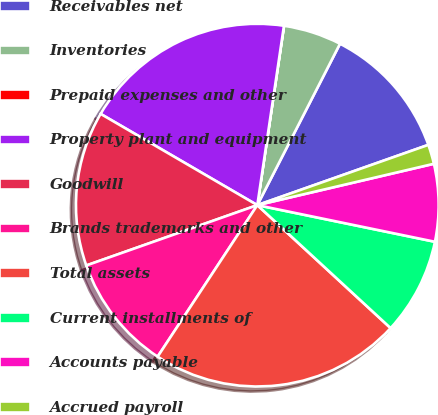<chart> <loc_0><loc_0><loc_500><loc_500><pie_chart><fcel>Receivables net<fcel>Inventories<fcel>Prepaid expenses and other<fcel>Property plant and equipment<fcel>Goodwill<fcel>Brands trademarks and other<fcel>Total assets<fcel>Current installments of<fcel>Accounts payable<fcel>Accrued payroll<nl><fcel>12.07%<fcel>5.18%<fcel>0.01%<fcel>18.95%<fcel>13.79%<fcel>10.34%<fcel>22.4%<fcel>8.62%<fcel>6.9%<fcel>1.73%<nl></chart> 